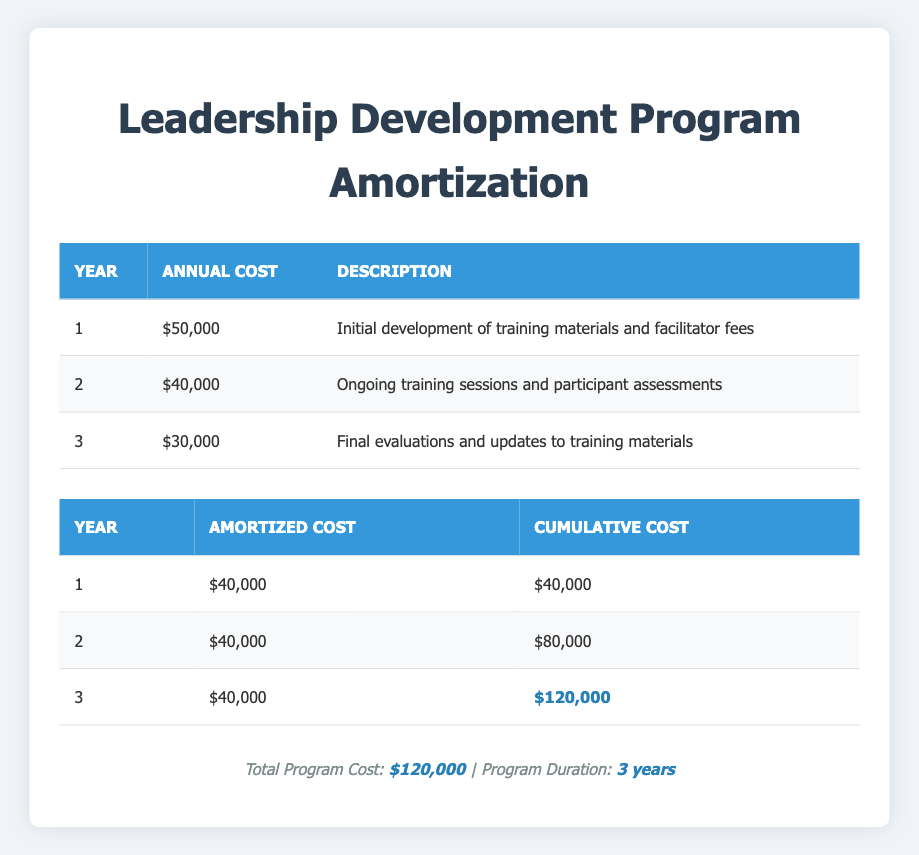What is the total cost of the Leadership Development Program? The total cost is listed in the footer of the table. It states that the total program cost is $120,000.
Answer: 120000 What was the annual cost for year 2 of the program? The annual cost breakdown table shows that for year 2, the cost is $40,000.
Answer: 40000 How much was the cumulative cost by the end of year 3? At the end of year 3, the cumulative cost is reported in the amortization schedule as $120,000.
Answer: 120000 Is the amortized cost the same for each year? The amortized cost for each year is consistently shown as $40,000, confirming that it is the same across all three years.
Answer: Yes What is the total amount spent in year 1 compared to the total amortized cost by the end of year 1? In year 1, the total amount spent was $50,000. The amortized cost indicated at the end of year 1 is $40,000. When compared, $50,000 is greater than $40,000.
Answer: $50,000 is greater What is the average annual cost breakdown over the three years of the program? The total annual cost is the sum of $50,000, $40,000, and $30,000, which is $120,000. The average is then calculated by dividing by 3 years, resulting in $120,000 / 3 = $40,000.
Answer: 40000 Which year had the lowest annual cost and what was that cost? Looking at the annual cost breakdown, year 3 has the lowest cost at $30,000, compared to years 1 and 2.
Answer: 30000 What would be the total cost of the program if the costs in years 2 and 3 were increased by 10%? First, increase the costs in year 2 ($40,000) and year 3 ($30,000) by 10%, resulting in new costs of $44,000 for year 2 and $33,000 for year 3. The new total would be $50,000 + $44,000 + $33,000 = $127,000.
Answer: 127000 If the amortization cost per year was increased to $50,000 for year 1 only, what would be the new cumulative cost by the end of year 3? The new amortized cost for year 1 would be $50,000, while for years 2 and 3, it remains at $40,000. Thus, the cumulative cost would be $50,000 + $40,000 + $40,000 = $130,000 at the end of year 3.
Answer: 130000 